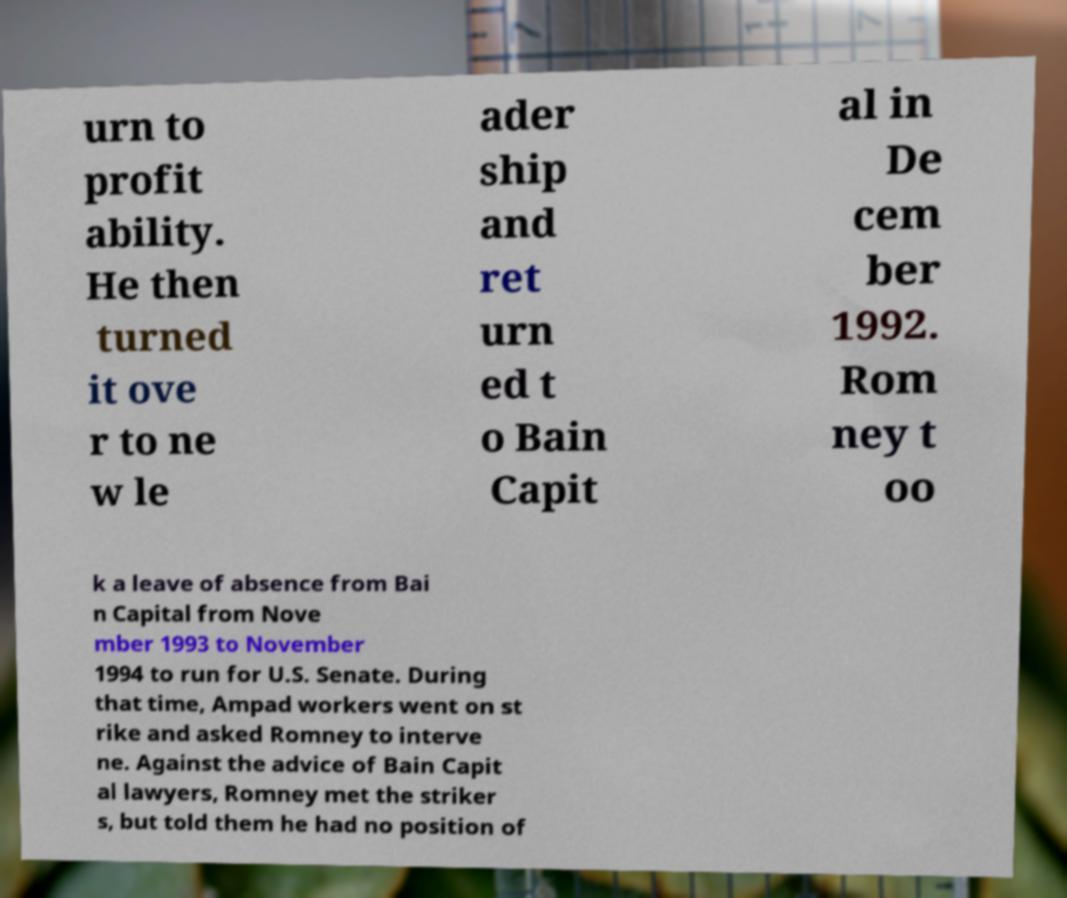Please identify and transcribe the text found in this image. urn to profit ability. He then turned it ove r to ne w le ader ship and ret urn ed t o Bain Capit al in De cem ber 1992. Rom ney t oo k a leave of absence from Bai n Capital from Nove mber 1993 to November 1994 to run for U.S. Senate. During that time, Ampad workers went on st rike and asked Romney to interve ne. Against the advice of Bain Capit al lawyers, Romney met the striker s, but told them he had no position of 